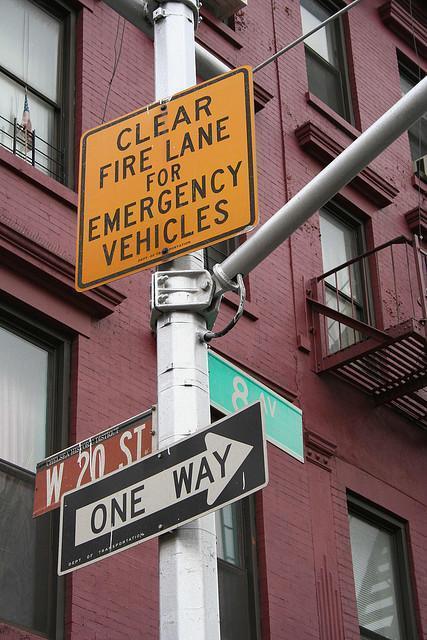How many words are in the very top sign?
Give a very brief answer. 6. How many "One Way" signs are there?
Give a very brief answer. 1. 